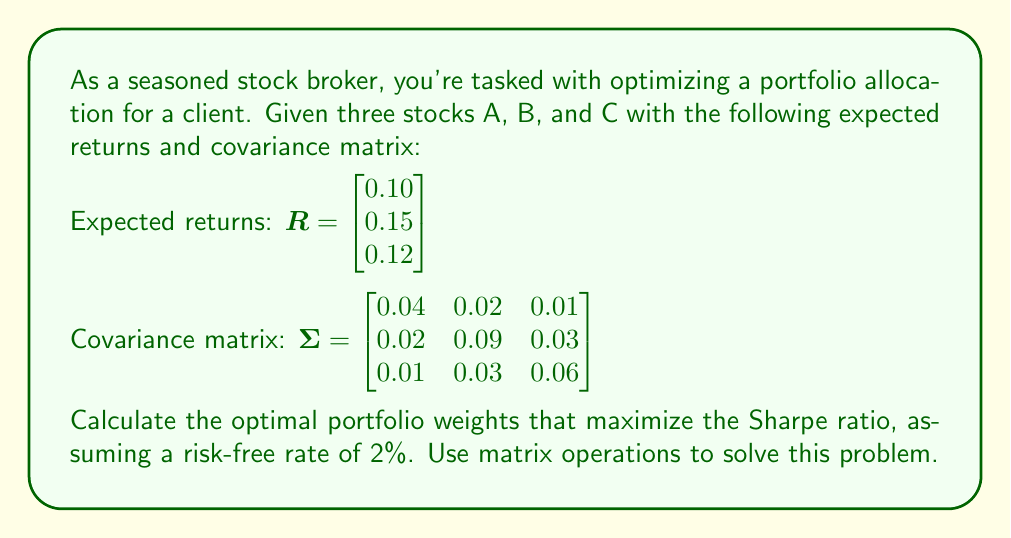What is the answer to this math problem? To solve this problem, we'll use the formula for the optimal portfolio weights that maximize the Sharpe ratio:

$$w = \frac{\Sigma^{-1}(R - R_f \cdot \mathbf{1})}{\mathbf{1}^T \Sigma^{-1}(R - R_f \cdot \mathbf{1})}$$

Where:
- $w$ is the vector of optimal weights
- $\Sigma$ is the covariance matrix
- $R$ is the vector of expected returns
- $R_f$ is the risk-free rate
- $\mathbf{1}$ is a vector of ones

Step 1: Calculate $R - R_f \cdot \mathbf{1}$
$$R - R_f \cdot \mathbf{1} = \begin{bmatrix} 0.10 \\ 0.15 \\ 0.12 \end{bmatrix} - 0.02 \cdot \begin{bmatrix} 1 \\ 1 \\ 1 \end{bmatrix} = \begin{bmatrix} 0.08 \\ 0.13 \\ 0.10 \end{bmatrix}$$

Step 2: Calculate $\Sigma^{-1}$
$$\Sigma^{-1} = \begin{bmatrix} 28.7037 & -5.5556 & -2.7778 \\ -5.5556 & 13.8889 & -4.1667 \\ -2.7778 & -4.1667 & 19.4444 \end{bmatrix}$$

Step 3: Calculate $\Sigma^{-1}(R - R_f \cdot \mathbf{1})$
$$\Sigma^{-1}(R - R_f \cdot \mathbf{1}) = \begin{bmatrix} 28.7037 & -5.5556 & -2.7778 \\ -5.5556 & 13.8889 & -4.1667 \\ -2.7778 & -4.1667 & 19.4444 \end{bmatrix} \begin{bmatrix} 0.08 \\ 0.13 \\ 0.10 \end{bmatrix} = \begin{bmatrix} 1.4444 \\ 1.1111 \\ 1.3889 \end{bmatrix}$$

Step 4: Calculate $\mathbf{1}^T \Sigma^{-1}(R - R_f \cdot \mathbf{1})$
$$\mathbf{1}^T \Sigma^{-1}(R - R_f \cdot \mathbf{1}) = \begin{bmatrix} 1 & 1 & 1 \end{bmatrix} \begin{bmatrix} 1.4444 \\ 1.1111 \\ 1.3889 \end{bmatrix} = 3.9444$$

Step 5: Calculate the optimal weights
$$w = \frac{\begin{bmatrix} 1.4444 \\ 1.1111 \\ 1.3889 \end{bmatrix}}{3.9444} = \begin{bmatrix} 0.3661 \\ 0.2817 \\ 0.3522 \end{bmatrix}$$

Therefore, the optimal portfolio weights that maximize the Sharpe ratio are approximately 36.61% for stock A, 28.17% for stock B, and 35.22% for stock C.
Answer: $w = \begin{bmatrix} 0.3661 \\ 0.2817 \\ 0.3522 \end{bmatrix}$ 